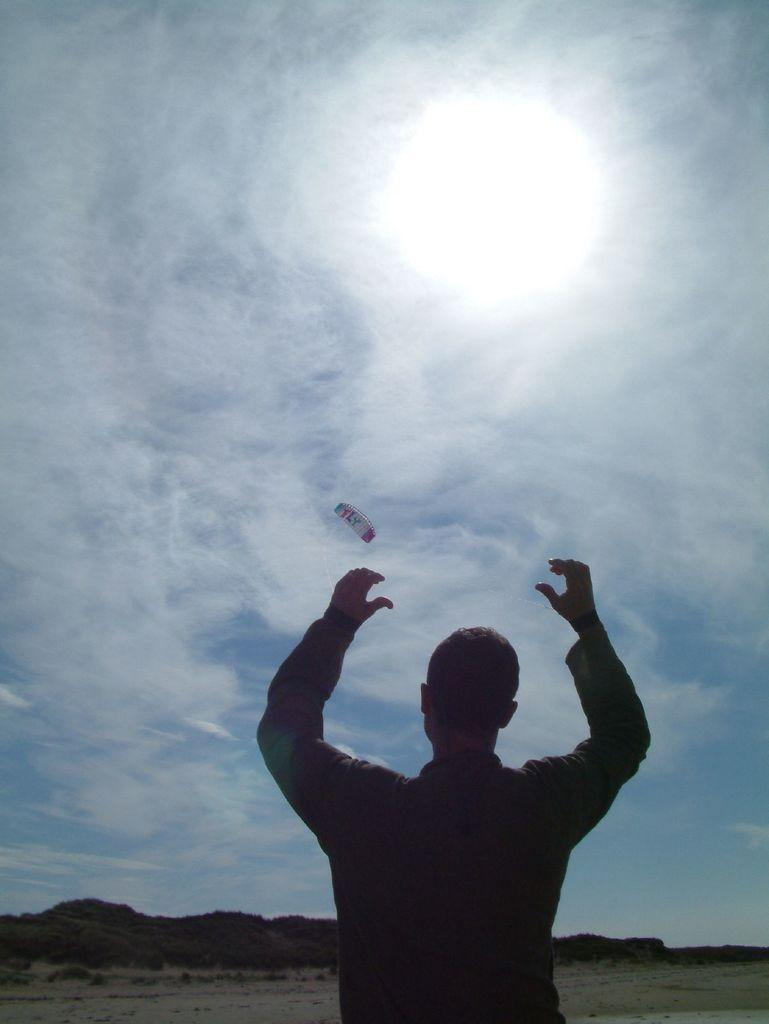What is the main subject of the image? There is a man standing in the image. What activity is taking place in the air? Paragliding is visible in the air. What can be seen in the background of the image? There are trees and the sky visible in the background of the image. What is the condition of the sky in the image? Clouds are present in the sky. What type of doll is sitting on the man's shoulder in the image? There is no doll present in the image; it only features a man and paragliding activity. What shape is the woman's hat in the image? There is no woman or hat present in the image. 